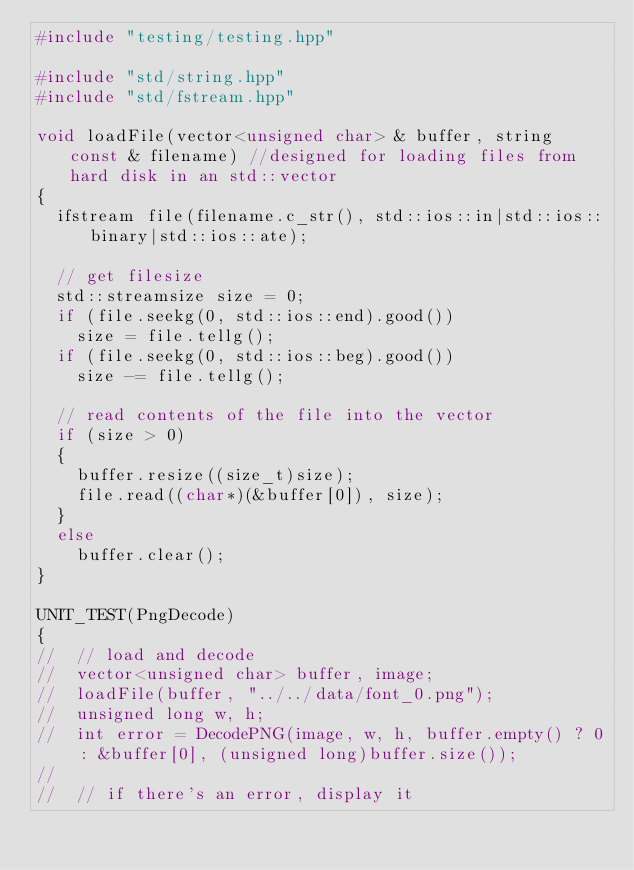<code> <loc_0><loc_0><loc_500><loc_500><_C++_>#include "testing/testing.hpp"

#include "std/string.hpp"
#include "std/fstream.hpp"

void loadFile(vector<unsigned char> & buffer, string const & filename) //designed for loading files from hard disk in an std::vector
{
  ifstream file(filename.c_str(), std::ios::in|std::ios::binary|std::ios::ate);

  // get filesize
  std::streamsize size = 0;
  if (file.seekg(0, std::ios::end).good())
    size = file.tellg();
  if (file.seekg(0, std::ios::beg).good())
    size -= file.tellg();

  // read contents of the file into the vector
  if (size > 0)
  {
    buffer.resize((size_t)size);
    file.read((char*)(&buffer[0]), size);
  }
  else
    buffer.clear();
}

UNIT_TEST(PngDecode)
{
//  // load and decode
//  vector<unsigned char> buffer, image;
//  loadFile(buffer, "../../data/font_0.png");
//  unsigned long w, h;
//  int error = DecodePNG(image, w, h, buffer.empty() ? 0 : &buffer[0], (unsigned long)buffer.size());
//
//  // if there's an error, display it</code> 